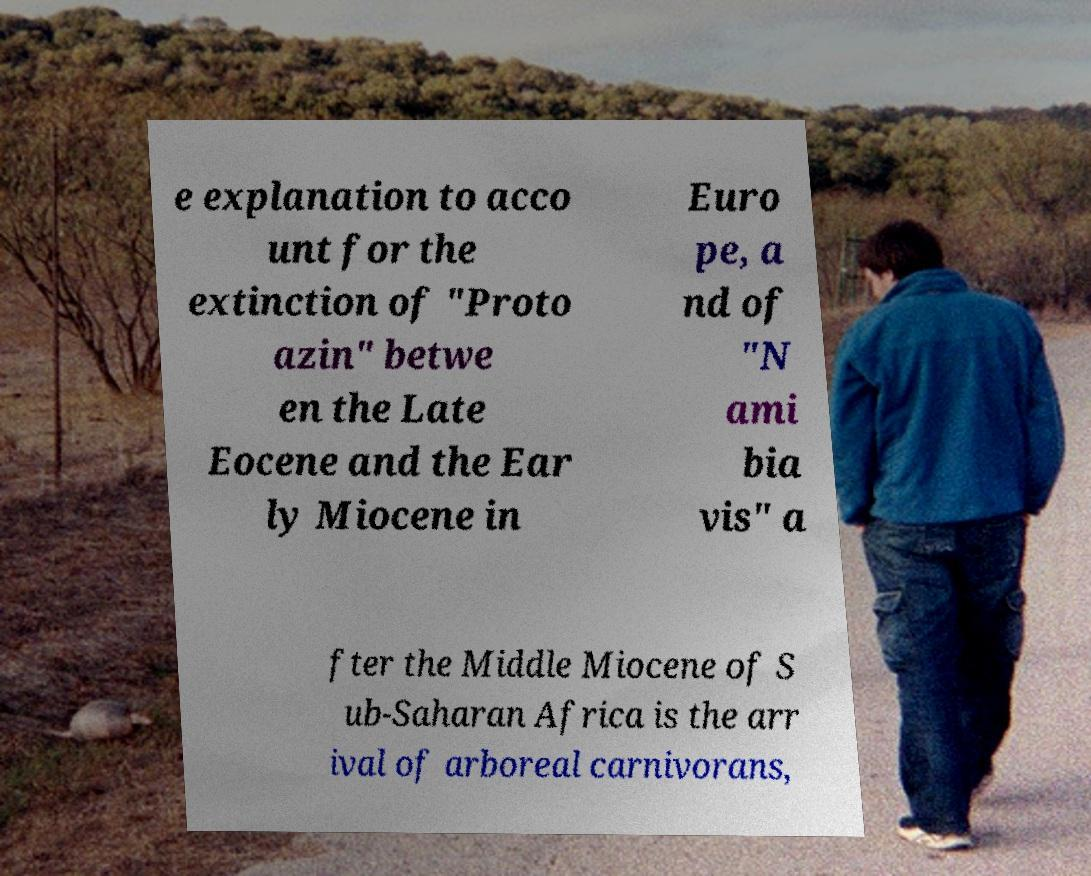Could you assist in decoding the text presented in this image and type it out clearly? e explanation to acco unt for the extinction of "Proto azin" betwe en the Late Eocene and the Ear ly Miocene in Euro pe, a nd of "N ami bia vis" a fter the Middle Miocene of S ub-Saharan Africa is the arr ival of arboreal carnivorans, 